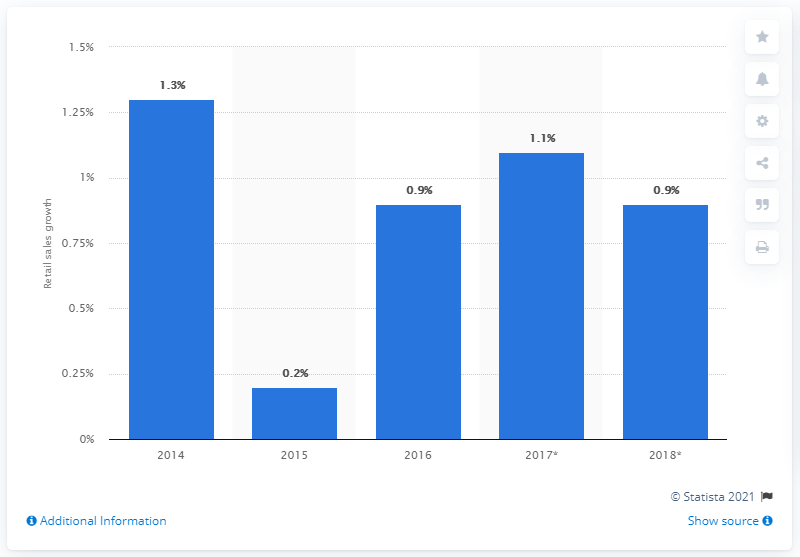Point out several critical features in this image. According to predictions, the expected increase in retail sales of food items in the UK in 2017 was 1.1%. It was expected that retail sales of food items in the UK would increase by 0.9% in 2018. 